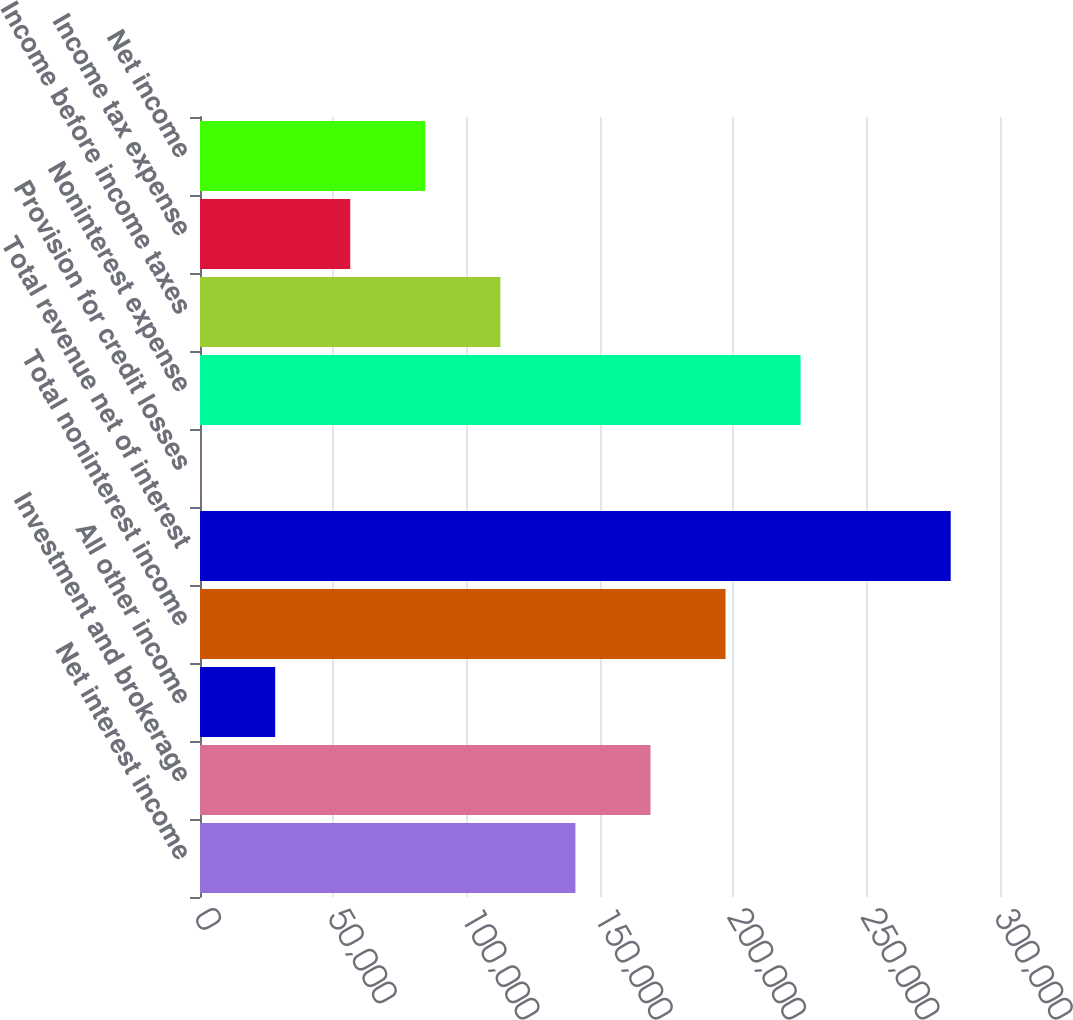Convert chart to OTSL. <chart><loc_0><loc_0><loc_500><loc_500><bar_chart><fcel>Net interest income<fcel>Investment and brokerage<fcel>All other income<fcel>Total noninterest income<fcel>Total revenue net of interest<fcel>Provision for credit losses<fcel>Noninterest expense<fcel>Income before income taxes<fcel>Income tax expense<fcel>Net income<nl><fcel>140786<fcel>168933<fcel>28202.1<fcel>197079<fcel>281517<fcel>56<fcel>225225<fcel>112640<fcel>56348.2<fcel>84494.3<nl></chart> 